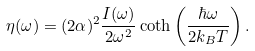Convert formula to latex. <formula><loc_0><loc_0><loc_500><loc_500>\eta ( \omega ) = ( 2 \alpha ) ^ { 2 } \frac { I ( \omega ) } { 2 \omega ^ { 2 } } \coth \left ( \frac { \hbar { \omega } } { 2 k _ { B } T } \right ) .</formula> 